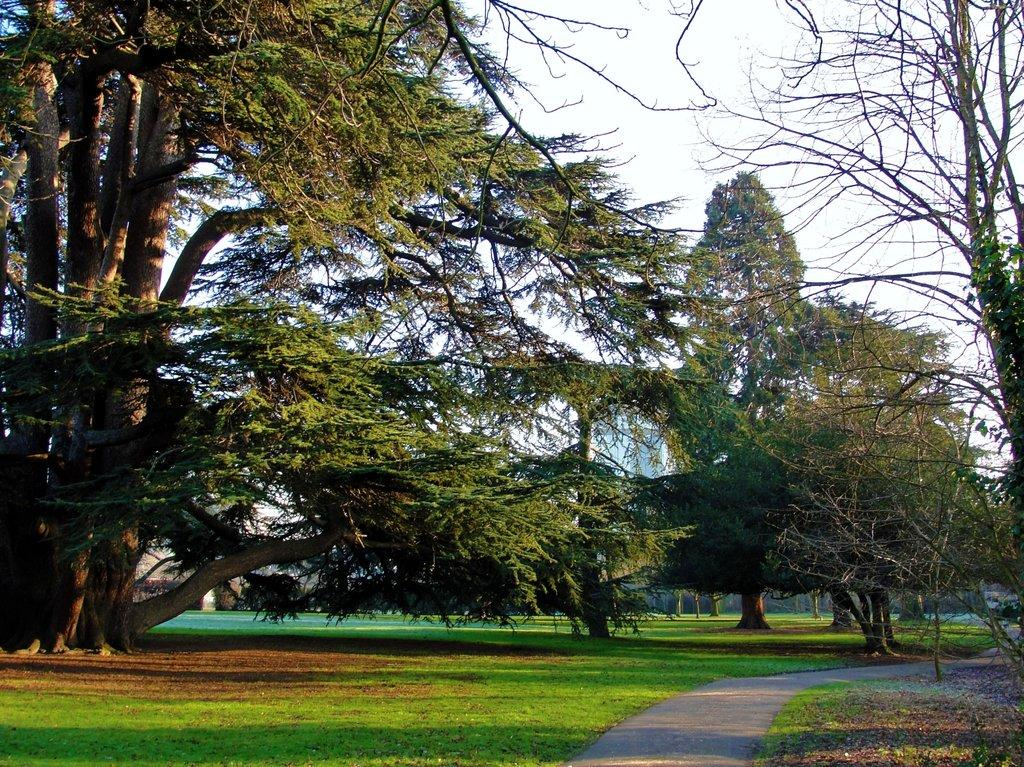What type of structures can be seen in the image? There are buildings in the image. What natural elements are present in the image? There are trees in the image. What can be seen at the bottom of the image? The ground is visible in the image. What type of pathway is present in the image? There is a road in the image. What is visible above the buildings and trees? The sky is visible in the image. What type of rock is being mined in the image? There is no rock or mining activity present in the image. What type of jeans are the people wearing in the image? There are no people or jeans present in the image. 